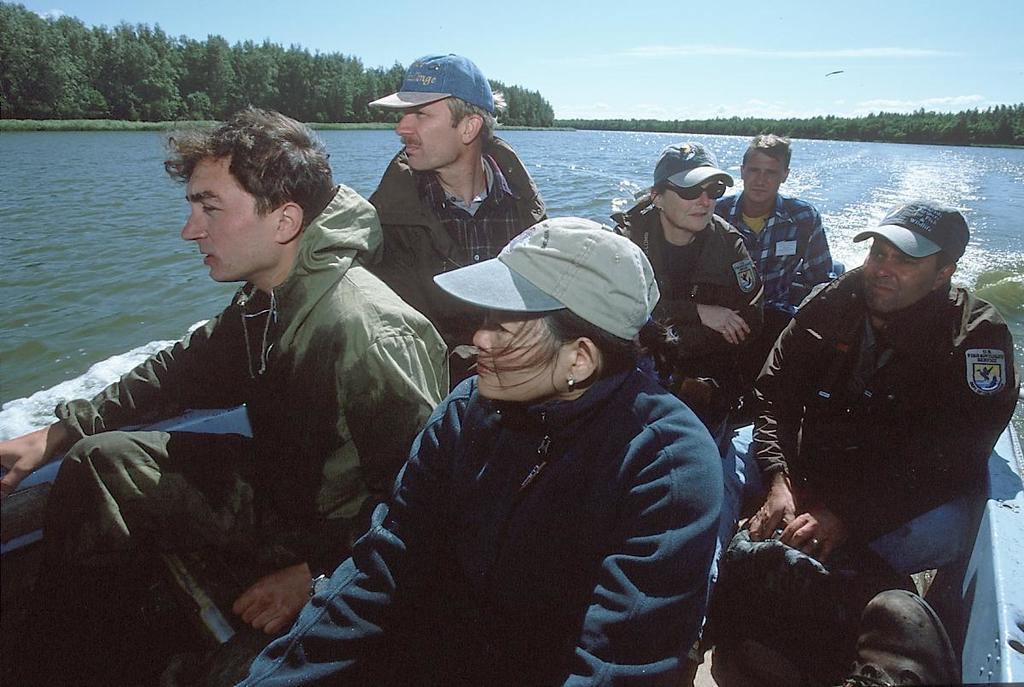Can you describe this image briefly? In this image in the front there are persons sitting on a boat. In the background there is water, there are trees and the sky is cloudy. 